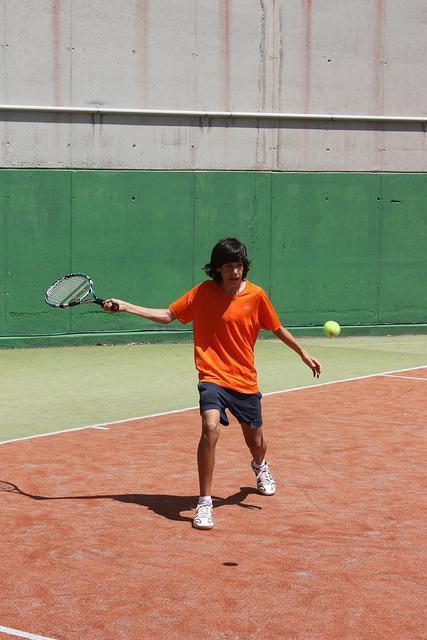How many sheep can be seen?
Give a very brief answer. 0. 